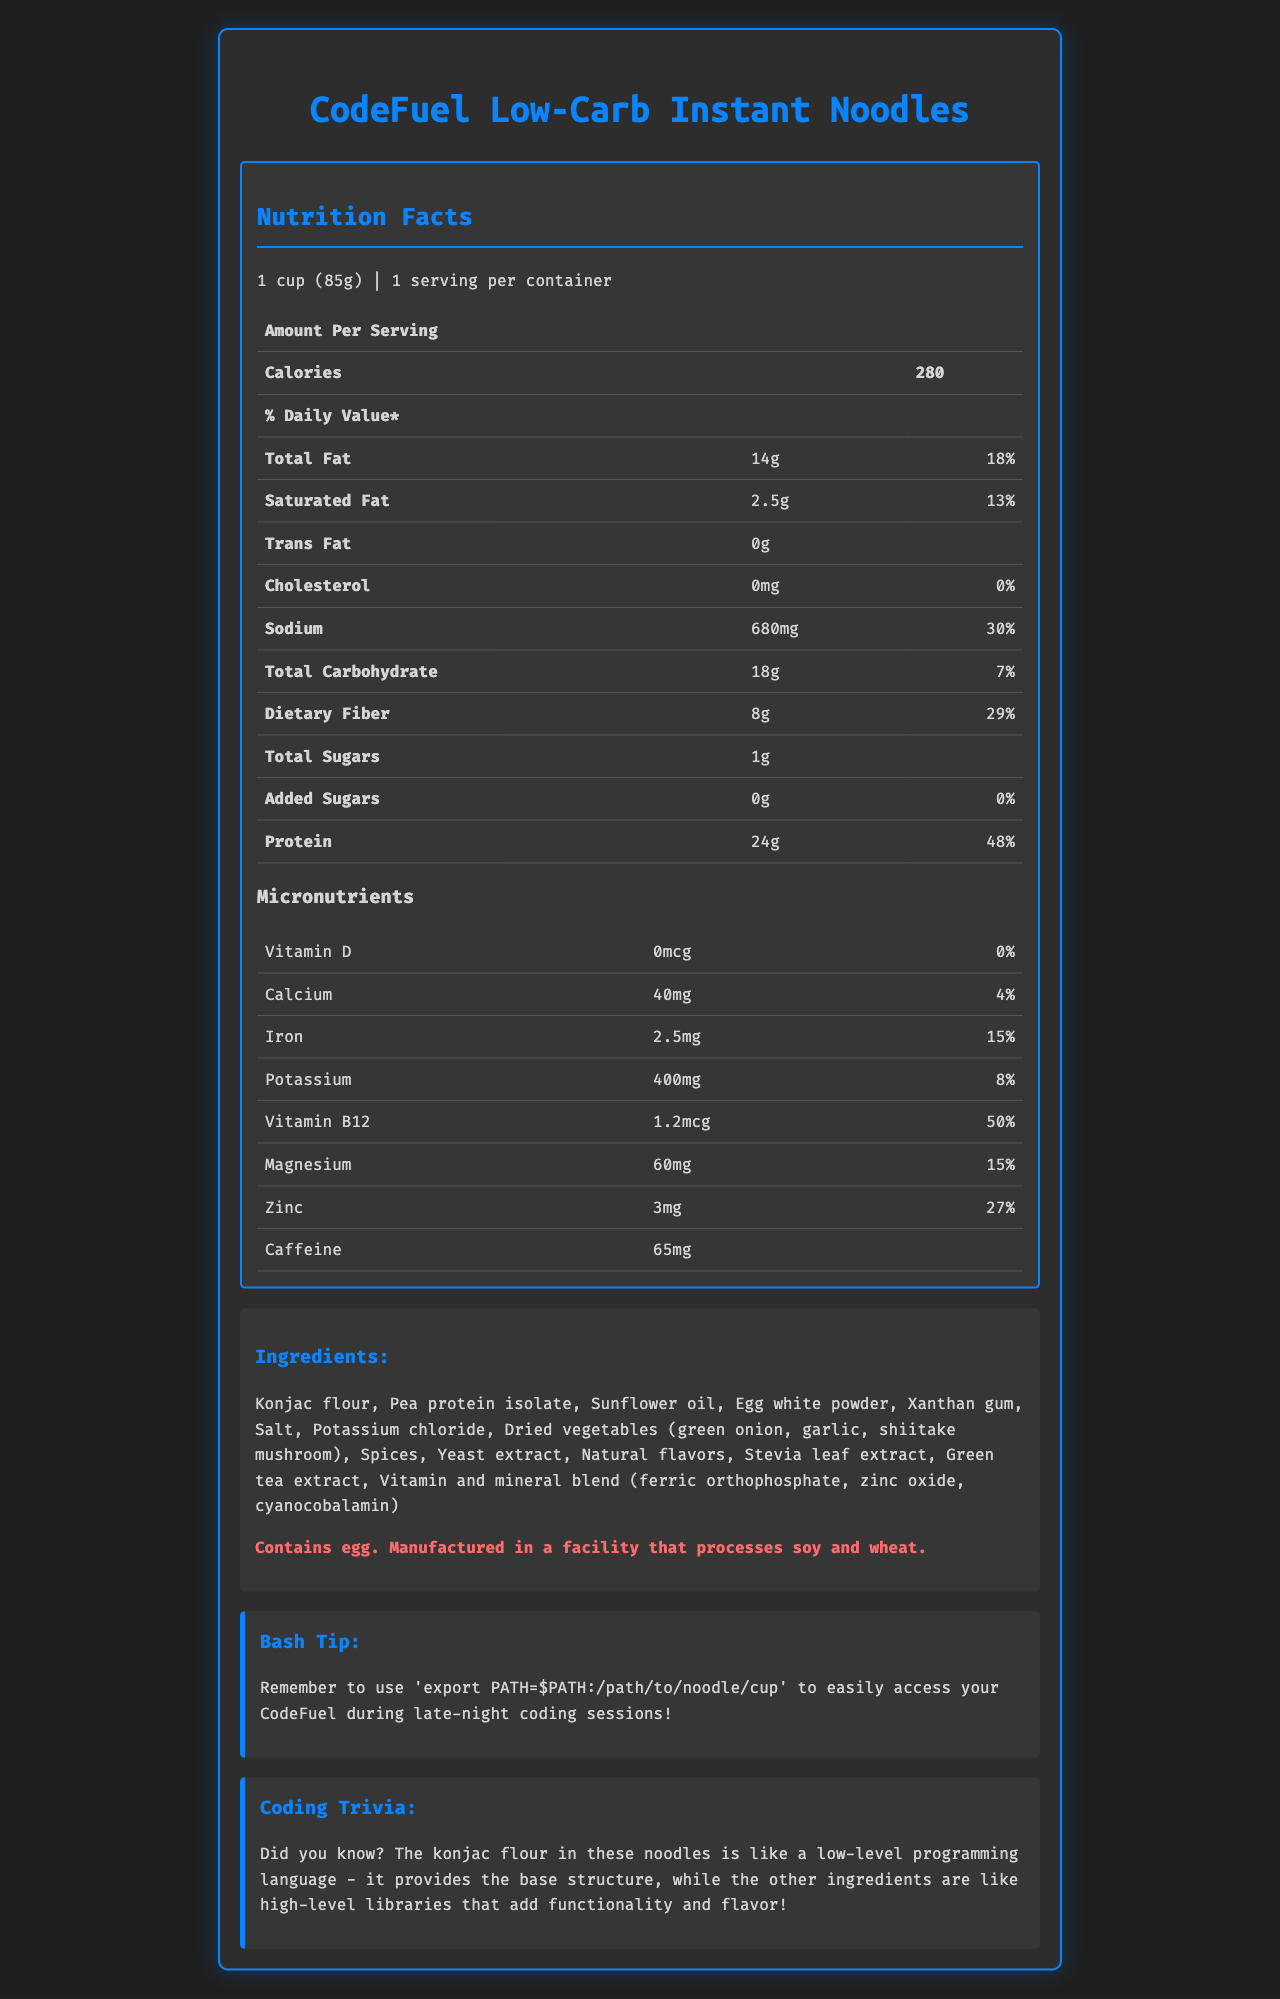what is the total fat content per serving? The total fat content is listed under the macronutrients section for one serving, and it is 14 grams.
Answer: 14g how many servings are in one container? The document states there is 1 serving per container.
Answer: 1 what is the percentage daily value of protein? The daily value percentage for protein is noted as 48% in the macronutrients section.
Answer: 48% how much dietary fiber is in one serving? The dietary fiber content for one serving is listed as 8 grams.
Answer: 8g does this product contain any added sugars? The document indicates that there are 0 grams of added sugars in the macronutrients section.
Answer: No which ingredient is not present in the list? A. Konjac flour B. Pea protein isolate C. Soy protein isolate Soy protein isolate is not listed among the ingredients; the document lists Konjac flour and Pea protein isolate.
Answer: C what is the main ingredient of the noodles? A. Pea protein isolate B. Sunflower oil C. Konjac flour D. Egg white powder The first listed ingredient is Konjac flour, which typically indicates it's the main ingredient.
Answer: C is there any cholesterol in this product? The document states that there is 0mg of cholesterol per serving.
Answer: No summarize the document in one sentence. The document presents detailed nutritional facts, including macronutrients and micronutrients, lists the ingredients and allergen info, and includes a bash tip and a coding trivia related to the product.
Answer: The document provides the nutritional information, ingredients, and additional tips for "CodeFuel Low-Carb Instant Noodles," a product designed for late-night coding sessions with a focus on low-carb content and high protein. how much vitamin D is in a serving? The micronutrients section shows that the amount of vitamin D is 0 micrograms per serving.
Answer: 0 mcg what are the dried vegetables included in the ingredients? A. Green onion and carrot B. Garlic and shiitake mushroom C. Green onion, garlic, and shiitake mushroom D. Bell pepper and spinach The ingredients list includes green onion, garlic, and shiitake mushroom as dried vegetables.
Answer: C what tip is given for using the product with bash? A. Use 'export PATH=$PATH:/path/to/noodle/cup' B. Use 'source /path/to/noodle/cup' C. Use 'alias noodle=/path/to/noodle/cup' The bash tip given is to use 'export PATH=$PATH:/path/to/noodle/cup'.
Answer: A what is the potassium content in one serving? The micronutrients section lists the potassium content as 400 milligrams.
Answer: 400 mg how much caffeine does the product contain? The micronutrients section indicates that the product contains 65 milligrams of caffeine.
Answer: 65 mg who manufactures the product? The document does not provide any information about the manufacturer of the product.
Answer: Not enough information 